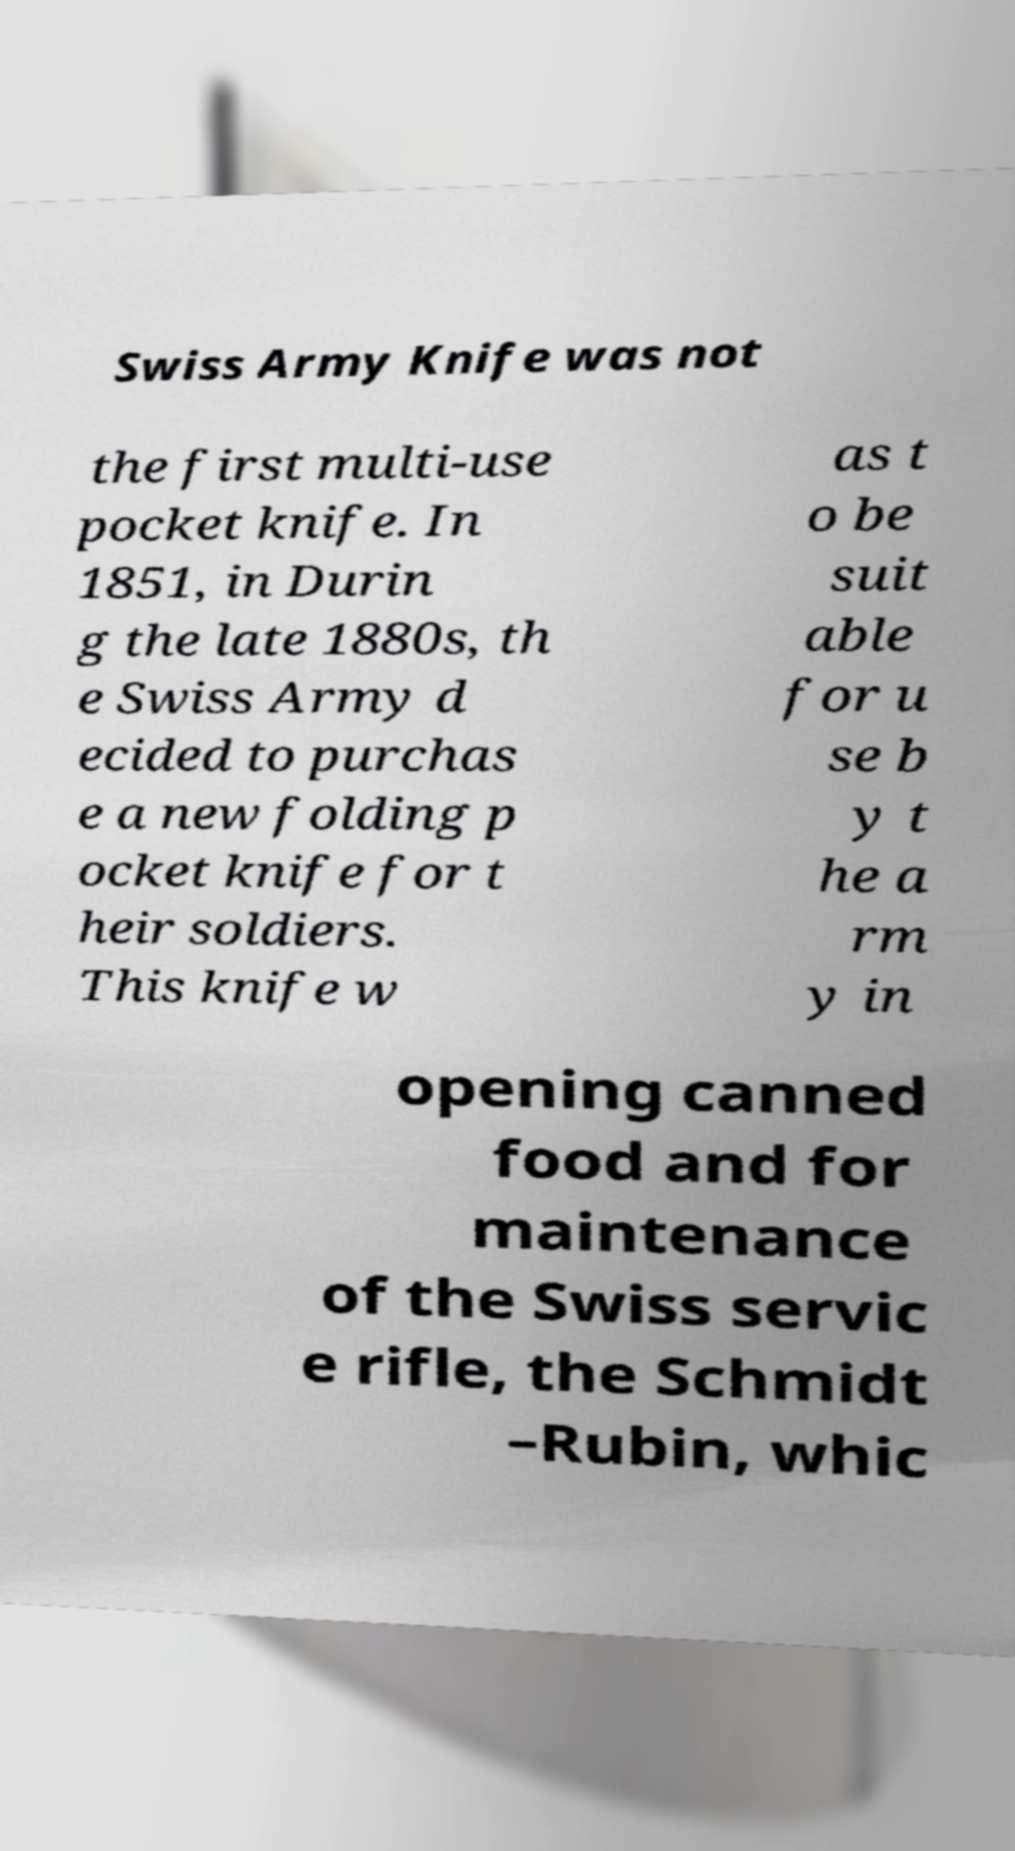What messages or text are displayed in this image? I need them in a readable, typed format. Swiss Army Knife was not the first multi-use pocket knife. In 1851, in Durin g the late 1880s, th e Swiss Army d ecided to purchas e a new folding p ocket knife for t heir soldiers. This knife w as t o be suit able for u se b y t he a rm y in opening canned food and for maintenance of the Swiss servic e rifle, the Schmidt –Rubin, whic 